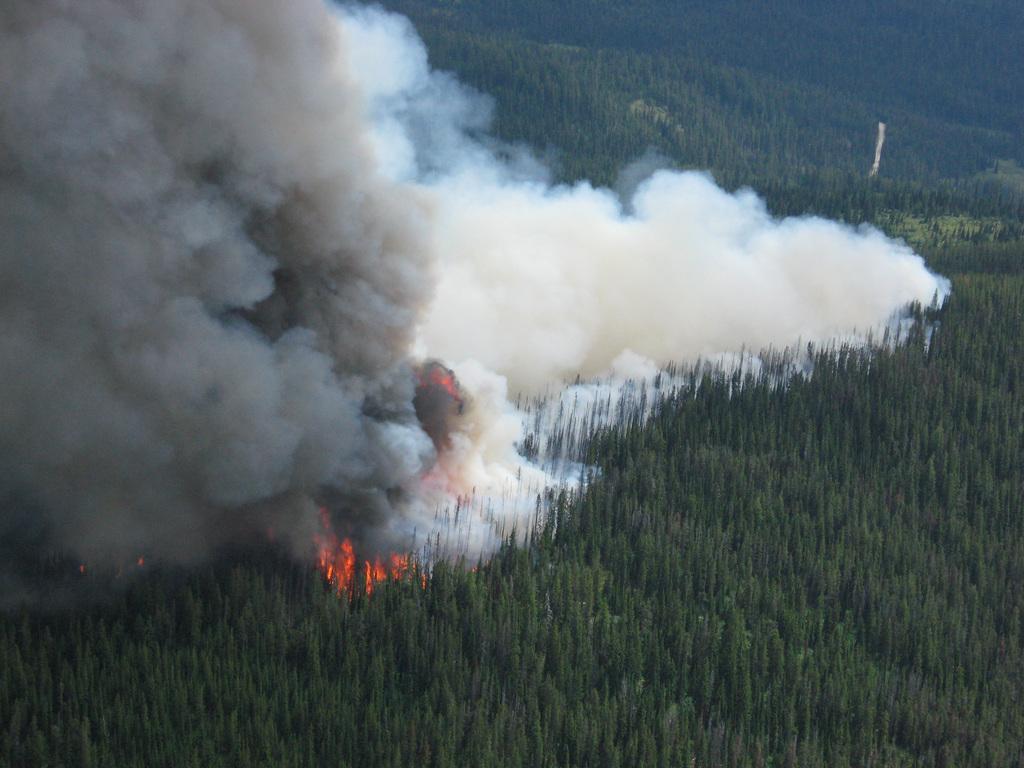In one or two sentences, can you explain what this image depicts? In this picture I can see trees and few trees caught fire and I can see smoke. 